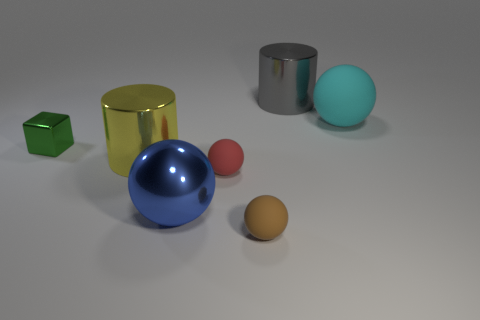What material is the big cylinder in front of the big cylinder that is behind the large cyan ball made of?
Provide a succinct answer. Metal. How many rubber objects are large yellow blocks or large cylinders?
Give a very brief answer. 0. There is a tiny object right of the tiny red object; are there any small rubber objects behind it?
Provide a short and direct response. Yes. How many things are tiny things that are right of the large blue thing or metal objects that are on the left side of the big metallic sphere?
Offer a terse response. 4. Is there anything else that is the same color as the big rubber thing?
Make the answer very short. No. The big rubber thing that is to the right of the large ball that is to the left of the tiny ball that is in front of the blue metal sphere is what color?
Offer a terse response. Cyan. What size is the sphere in front of the large shiny thing in front of the tiny red ball?
Offer a very short reply. Small. There is a thing that is behind the large yellow metallic cylinder and to the left of the blue metallic sphere; what is its material?
Your answer should be compact. Metal. Is the size of the cyan matte thing the same as the rubber ball that is in front of the blue metallic sphere?
Give a very brief answer. No. Are there any blue things?
Ensure brevity in your answer.  Yes. 